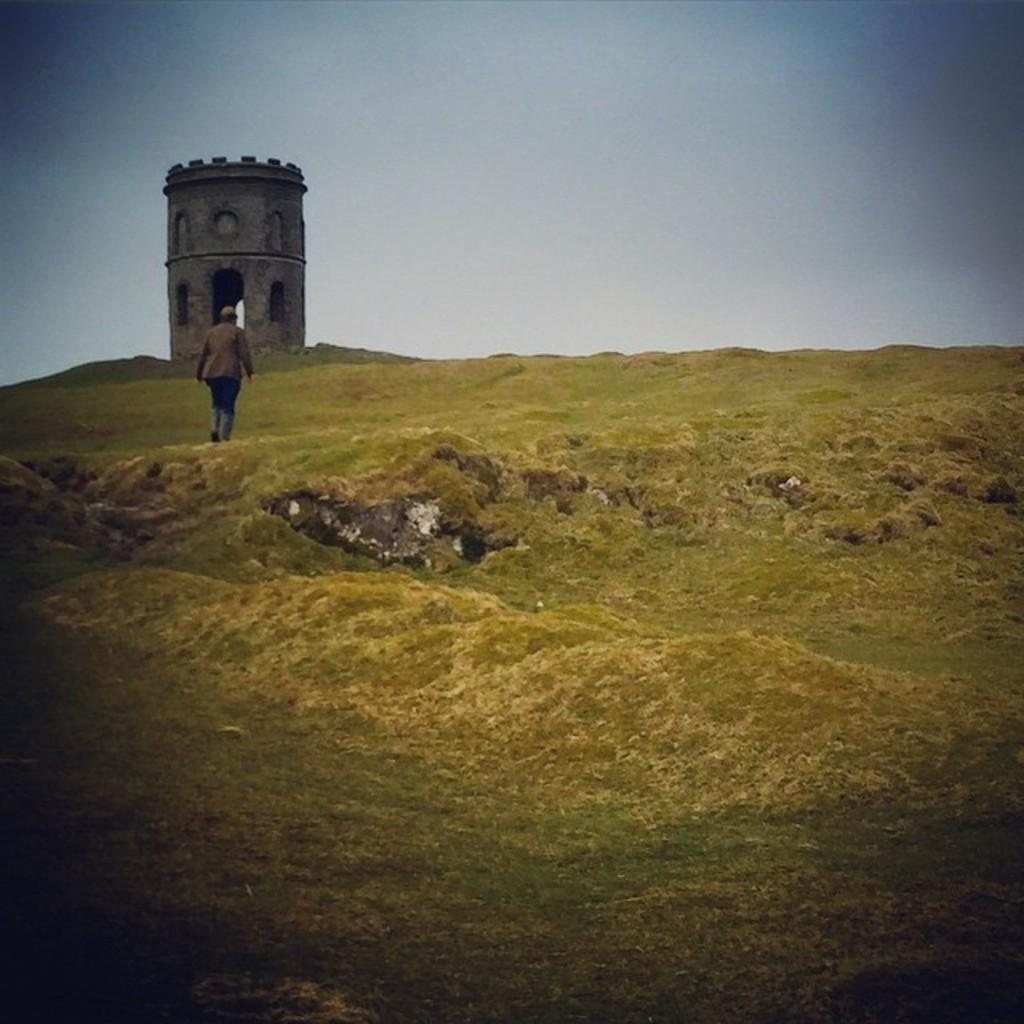Who is present in the image? There is a man in the image. What is the man doing in the image? The man is walking on a hill area. What can be seen in the background of the image? There is a small tower in the background of the image. How would you describe the weather in the image? The sky is cloudy in the image. What type of tooth is visible in the image? There is no tooth present in the image. Is there a beggar in the image? There is no mention of a beggar in the image; it features a man walking on a hill area. 